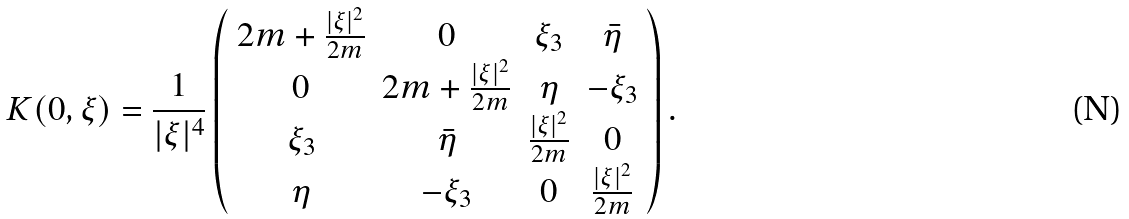<formula> <loc_0><loc_0><loc_500><loc_500>K ( 0 , \xi ) = \frac { 1 } { | \xi | ^ { 4 } } \left ( \begin{array} { c c c c } 2 m + \frac { | \xi | ^ { 2 } } { 2 m } & 0 & \xi _ { 3 } & \bar { \eta } \\ 0 & 2 m + \frac { | \xi | ^ { 2 } } { 2 m } & \eta & - \xi _ { 3 } \\ \xi _ { 3 } & \bar { \eta } & \frac { | \xi | ^ { 2 } } { 2 m } & 0 \\ \eta & - \xi _ { 3 } & 0 & \frac { | \xi | ^ { 2 } } { 2 m } \end{array} \right ) .</formula> 